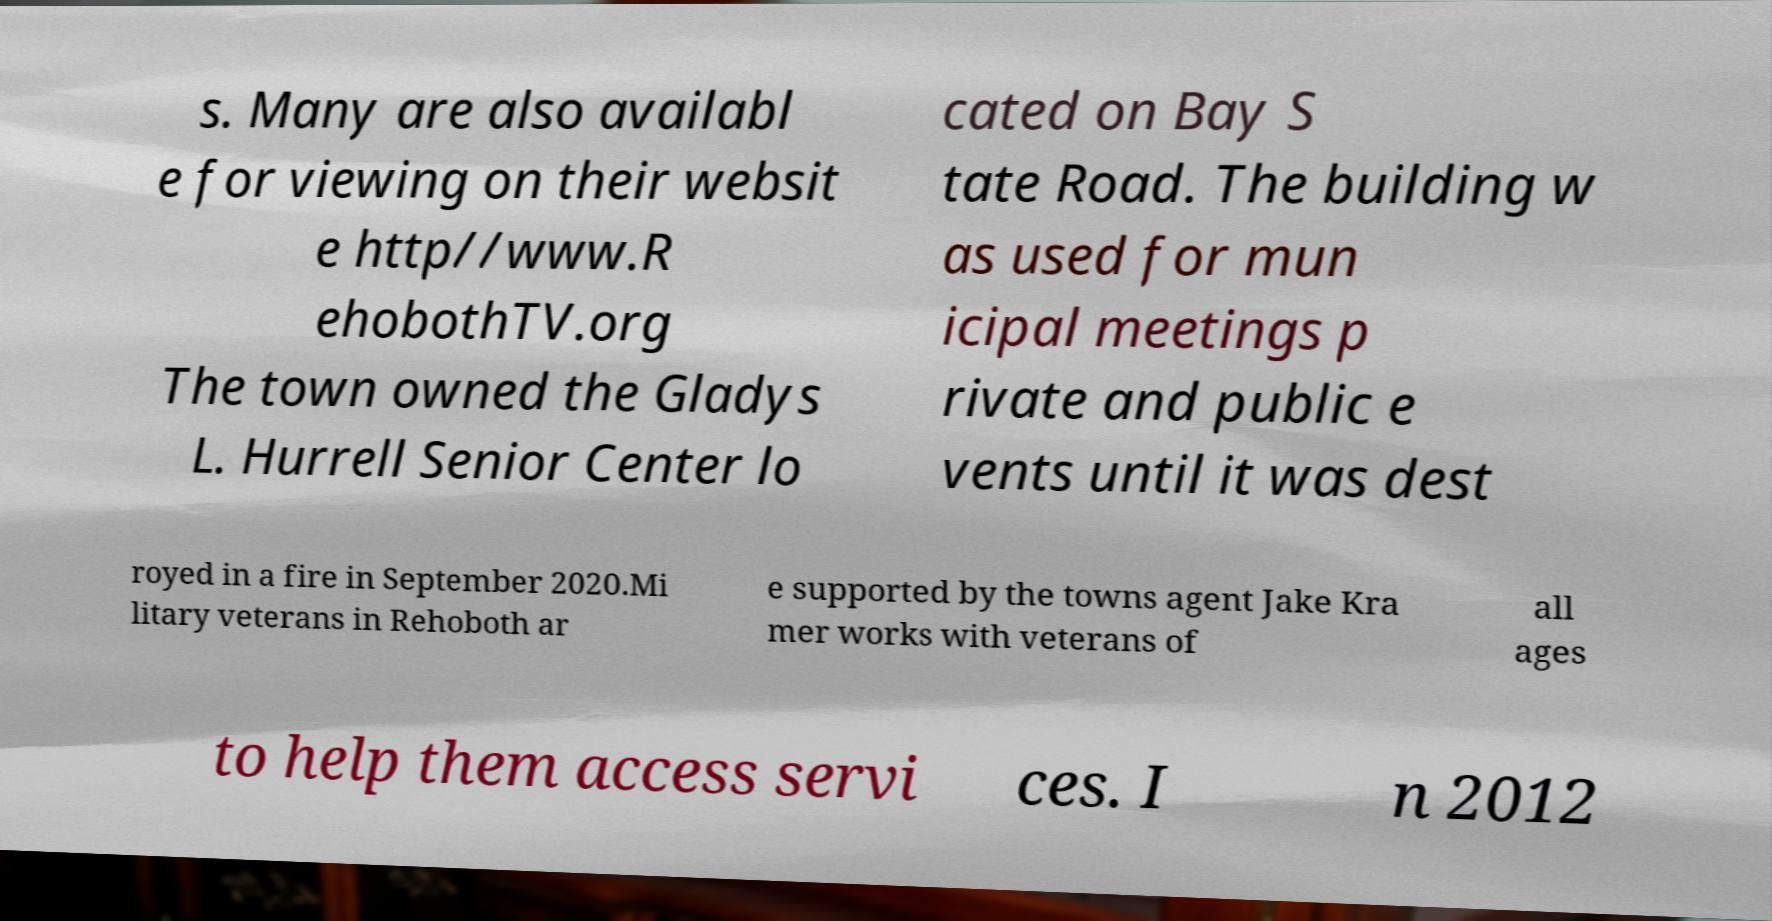For documentation purposes, I need the text within this image transcribed. Could you provide that? s. Many are also availabl e for viewing on their websit e http//www.R ehobothTV.org The town owned the Gladys L. Hurrell Senior Center lo cated on Bay S tate Road. The building w as used for mun icipal meetings p rivate and public e vents until it was dest royed in a fire in September 2020.Mi litary veterans in Rehoboth ar e supported by the towns agent Jake Kra mer works with veterans of all ages to help them access servi ces. I n 2012 